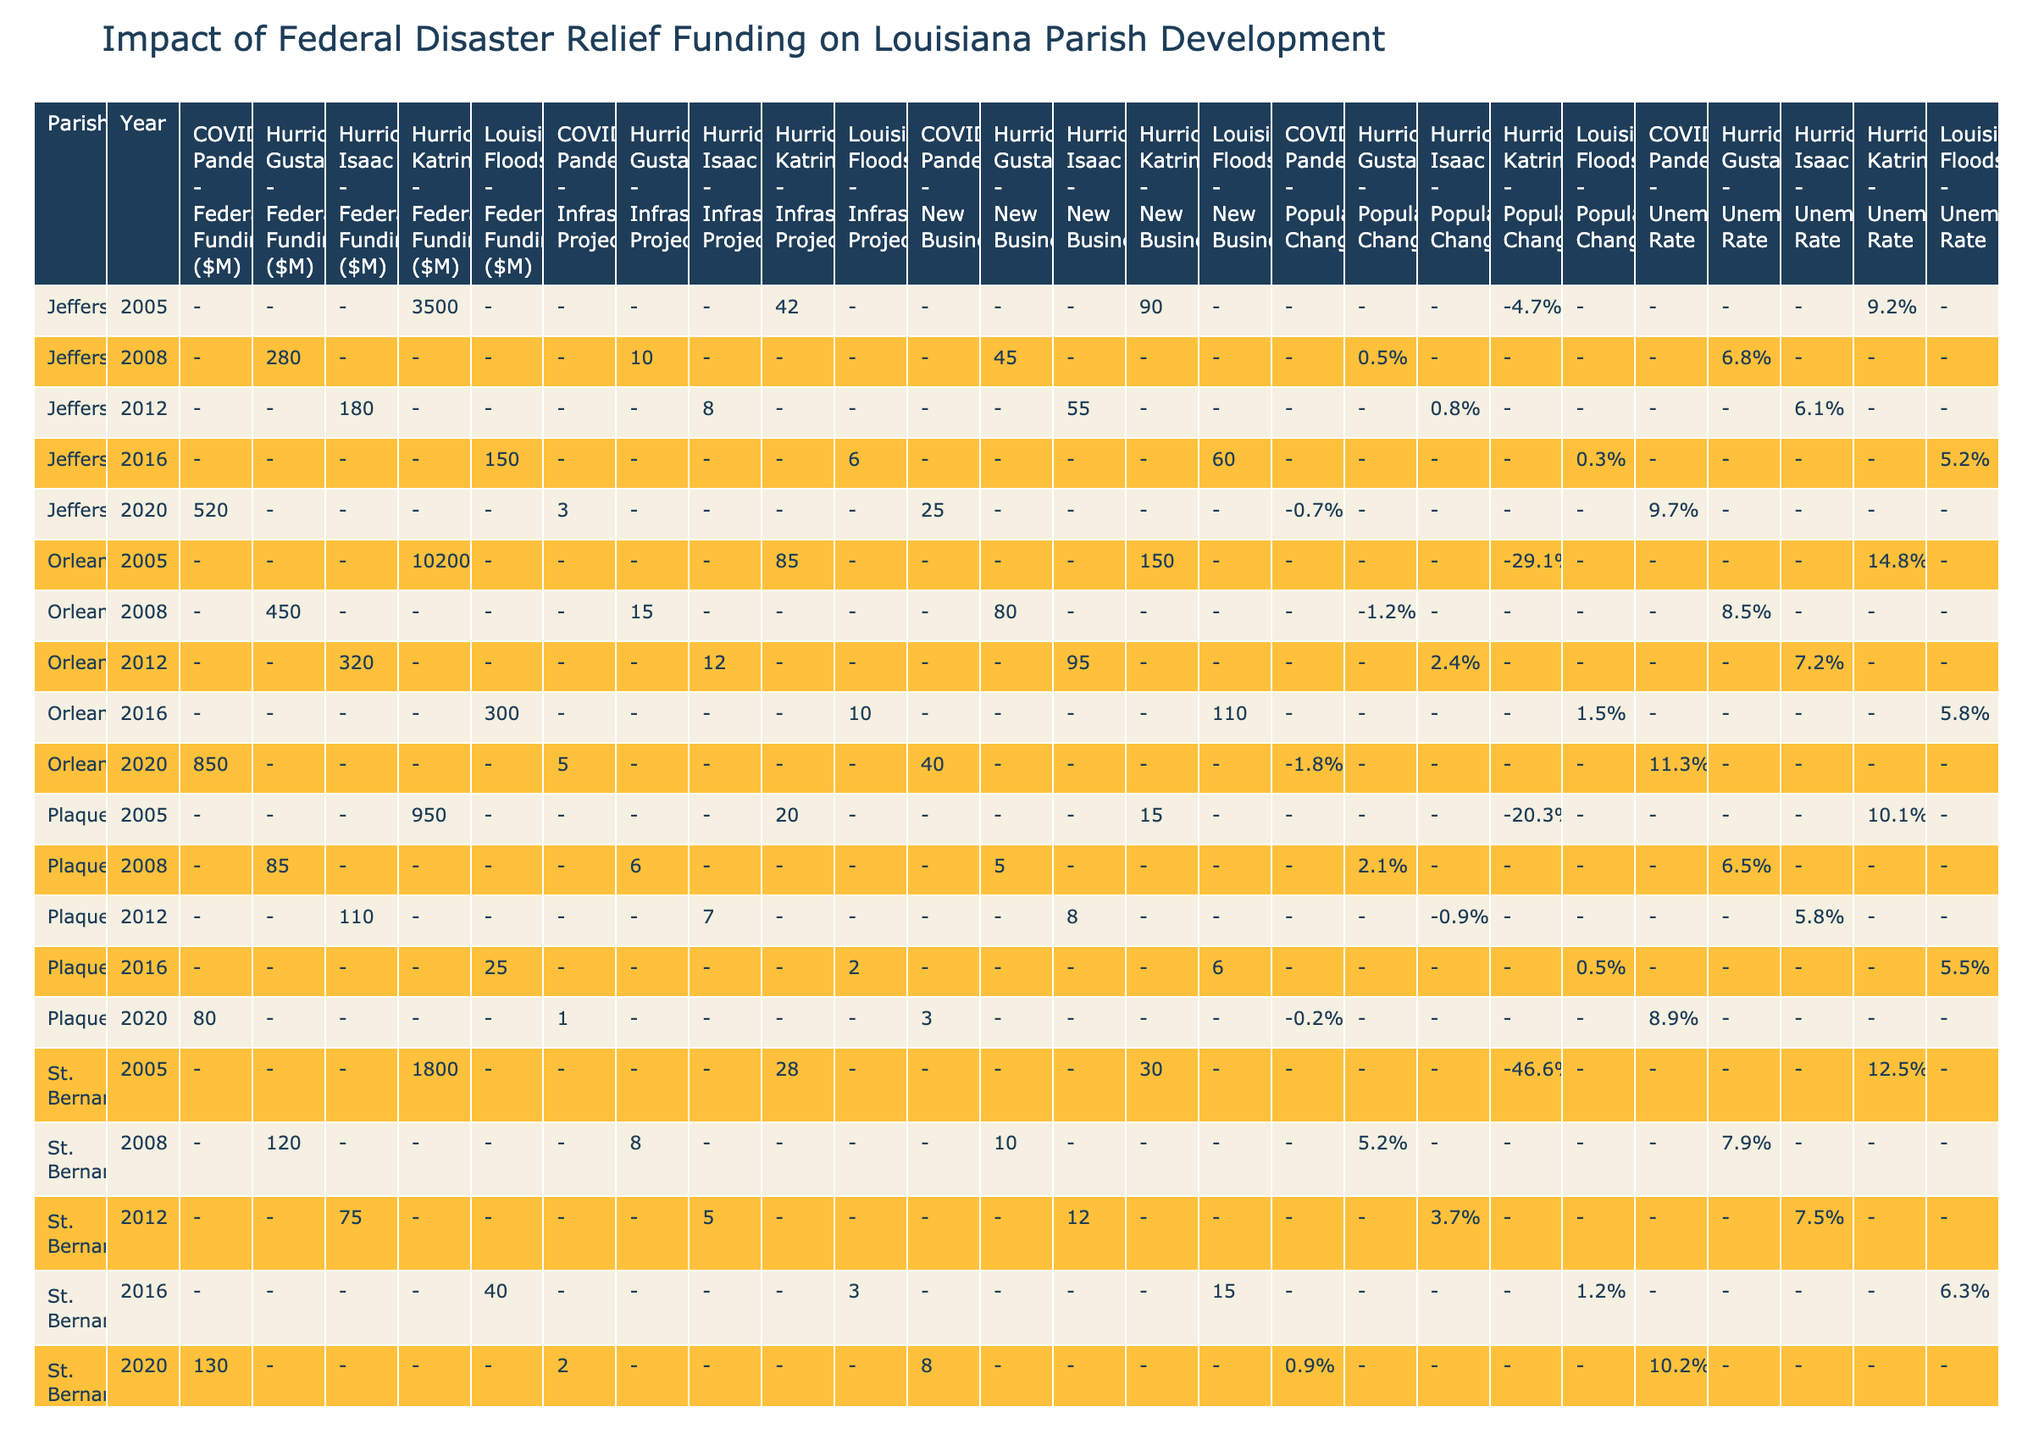What was the total federal funding for Orleans parish in 2005? In the table, the federal funding for Orleans parish in 2005 due to Hurricane Katrina is listed as 10,200 million dollars.
Answer: 10,200 million dollars How many new businesses were established in Jefferson parish after Hurricane Gustav in 2008? According to the table, Jefferson parish had 45 new businesses established in 2008 following Hurricane Gustav.
Answer: 45 What is the unemployment rate for Plaquemines parish in the year 2012? The table shows that the unemployment rate for Plaquemines parish in 2012 after Hurricane Isaac is 5.8%.
Answer: 5.8% Which parish experienced the highest population decrease, and what was the percentage? St. Bernard parish had the highest population decrease of -46.6% in 2005 due to Hurricane Katrina, compared to other parishes in that year.
Answer: St. Bernard parish with -46.6% Was the federal funding for St. Bernard parish higher in 2016 compared to 2012? In 2016, St. Bernard parish received 40 million dollars, while in 2012 it received 75 million dollars. Thus, the funding in 2016 was lower.
Answer: No What was the change in new businesses from 2005 to 2016 in Orleans parish? In 2005, Orleans parish had 150 new businesses (after Katrina), and by 2016 (after the Louisiana Floods), it had 110 new businesses. The change is 110 - 150 = -40, indicating a reduction in new businesses.
Answer: -40 What is the average federal funding received by Jefferson parish across all years listed? The federal funding amounts across the relevant years for Jefferson parish are: 3,500 (2005), 280 (2008), 180 (2012), 150 (2016), and 520 (2020). Adding these gives a total of 4,630. Dividing by the 5 years gives the average: 4,630 / 5 = 926.
Answer: 926 million dollars Which parish had the least federal funding in 2005, and how much was it? In 2005, Plaquemines parish had the least federal funding with a total of 950 million dollars.
Answer: Plaquemines parish with 950 million dollars How did the number of infrastructure projects change for Orleans parish between 2012 and 2016? In 2012, Orleans parish had 12 infrastructure projects following Hurricane Isaac, and in 2016, it had 10 after the Louisiana Floods. Thus, the change is 10 - 12 = -2, indicating a decrease.
Answer: -2 